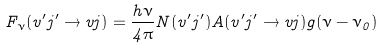<formula> <loc_0><loc_0><loc_500><loc_500>F _ { \nu } ( v ^ { \prime } j ^ { \prime } \rightarrow v j ) = \frac { h \nu } { 4 \pi } N ( v ^ { \prime } j ^ { \prime } ) A ( v ^ { \prime } j ^ { \prime } \rightarrow v j ) g ( \nu - \nu _ { 0 } )</formula> 